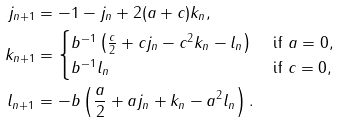<formula> <loc_0><loc_0><loc_500><loc_500>j _ { n + 1 } & = - 1 - j _ { n } + 2 ( a + c ) k _ { n } , \\ k _ { n + 1 } & = \begin{cases} b ^ { - 1 } \left ( \frac { c } { 2 } + c j _ { n } - c ^ { 2 } k _ { n } - l _ { n } \right ) & \text { if $a=0$} , \\ b ^ { - 1 } l _ { n } & \text { if $c=0$} , \end{cases} \\ l _ { n + 1 } & = - b \left ( \frac { a } { 2 } + a j _ { n } + k _ { n } - a ^ { 2 } l _ { n } \right ) .</formula> 